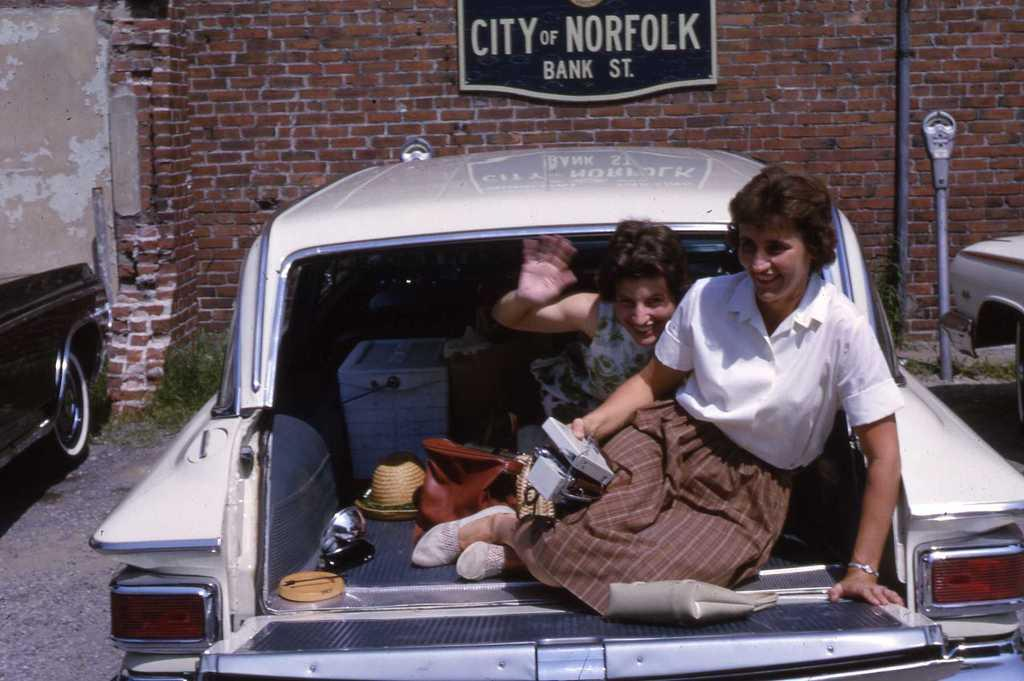How many women are in the image? There are two women in the image. Where are the women seated? The women are seated in the trunk of a car. What items can be seen in the trunk with the women? There is a handbag and hats in the trunk. What is visible in the background of the image? There is a wall visible in the image, and cars parked on the side. What type of dust can be seen on the bucket in the image? There is no bucket present in the image, so it is not possible to determine if there is any dust on it. 